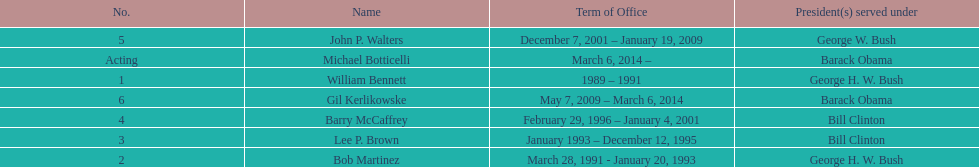Would you be able to parse every entry in this table? {'header': ['No.', 'Name', 'Term of Office', 'President(s) served under'], 'rows': [['5', 'John P. Walters', 'December 7, 2001 – January 19, 2009', 'George W. Bush'], ['Acting', 'Michael Botticelli', 'March 6, 2014 –', 'Barack Obama'], ['1', 'William Bennett', '1989 – 1991', 'George H. W. Bush'], ['6', 'Gil Kerlikowske', 'May 7, 2009 – March 6, 2014', 'Barack Obama'], ['4', 'Barry McCaffrey', 'February 29, 1996 – January 4, 2001', 'Bill Clinton'], ['3', 'Lee P. Brown', 'January 1993 – December 12, 1995', 'Bill Clinton'], ['2', 'Bob Martinez', 'March 28, 1991 - January 20, 1993', 'George H. W. Bush']]} What were the total number of years bob martinez served in office? 2. 